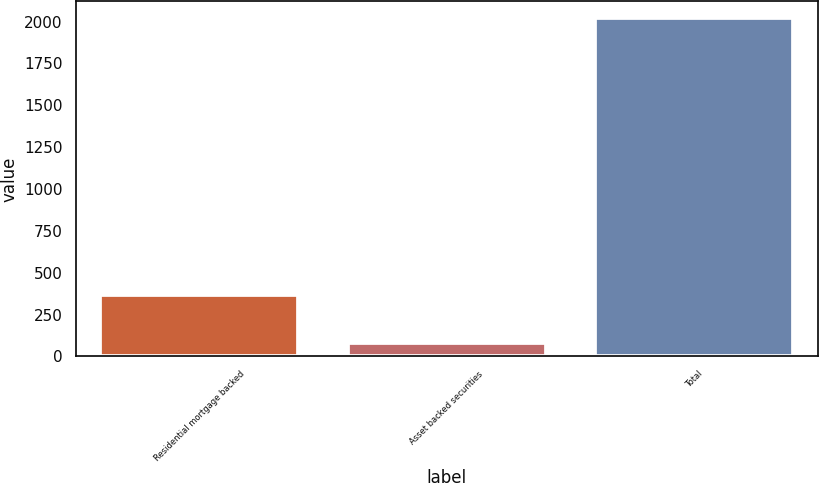Convert chart to OTSL. <chart><loc_0><loc_0><loc_500><loc_500><bar_chart><fcel>Residential mortgage backed<fcel>Asset backed securities<fcel>Total<nl><fcel>368<fcel>78<fcel>2020<nl></chart> 